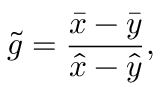Convert formula to latex. <formula><loc_0><loc_0><loc_500><loc_500>\tilde { g } = \frac { \bar { x } - \bar { y } } { \hat { x } - \hat { y } } ,</formula> 